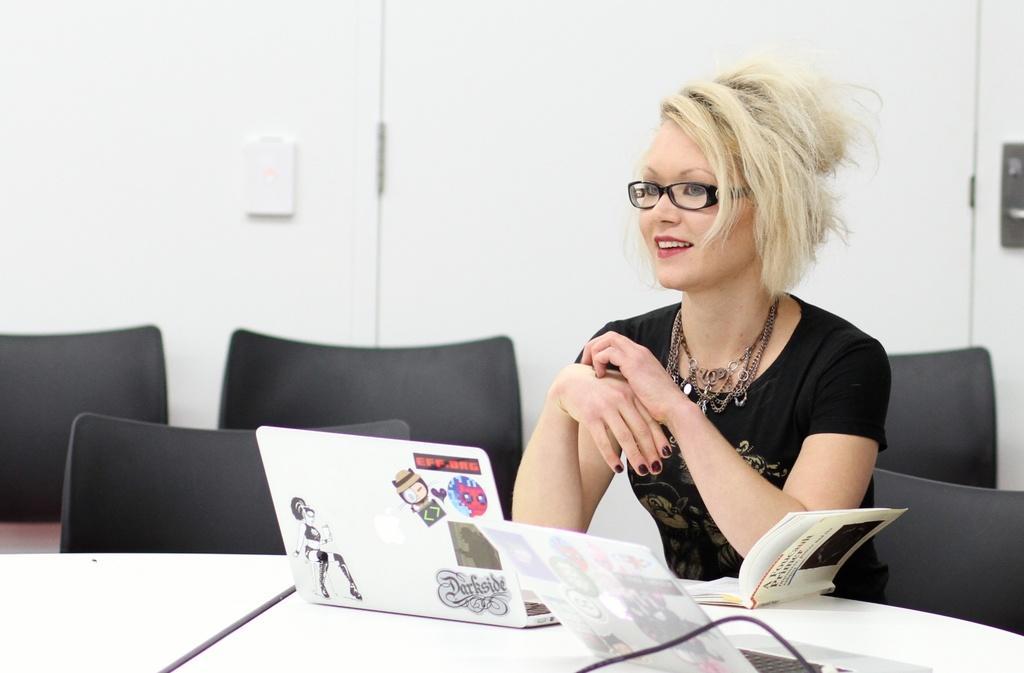Can you describe this image briefly? In the middle there is a table on that table there is a laptop and book. On the right there is a woman she wear black t shirt ,she is smiling ,her hair is short. In the background there are many empty chairs ,wall and door. 